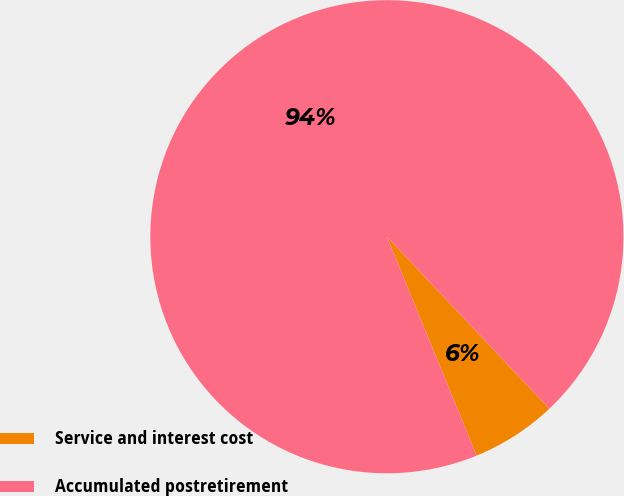<chart> <loc_0><loc_0><loc_500><loc_500><pie_chart><fcel>Service and interest cost<fcel>Accumulated postretirement<nl><fcel>5.85%<fcel>94.15%<nl></chart> 